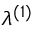Convert formula to latex. <formula><loc_0><loc_0><loc_500><loc_500>\lambda ^ { ( 1 ) }</formula> 